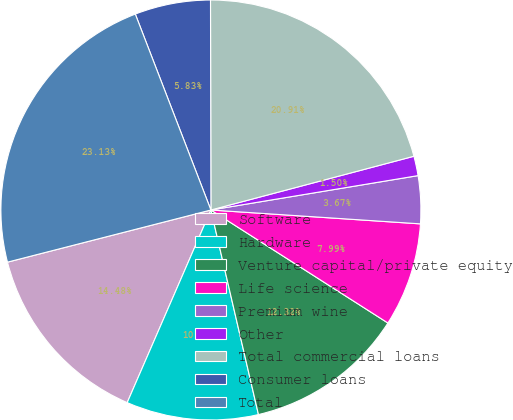Convert chart. <chart><loc_0><loc_0><loc_500><loc_500><pie_chart><fcel>Software<fcel>Hardware<fcel>Venture capital/private equity<fcel>Life science<fcel>Premium wine<fcel>Other<fcel>Total commercial loans<fcel>Consumer loans<fcel>Total<nl><fcel>14.48%<fcel>10.16%<fcel>12.32%<fcel>7.99%<fcel>3.67%<fcel>1.5%<fcel>20.91%<fcel>5.83%<fcel>23.13%<nl></chart> 